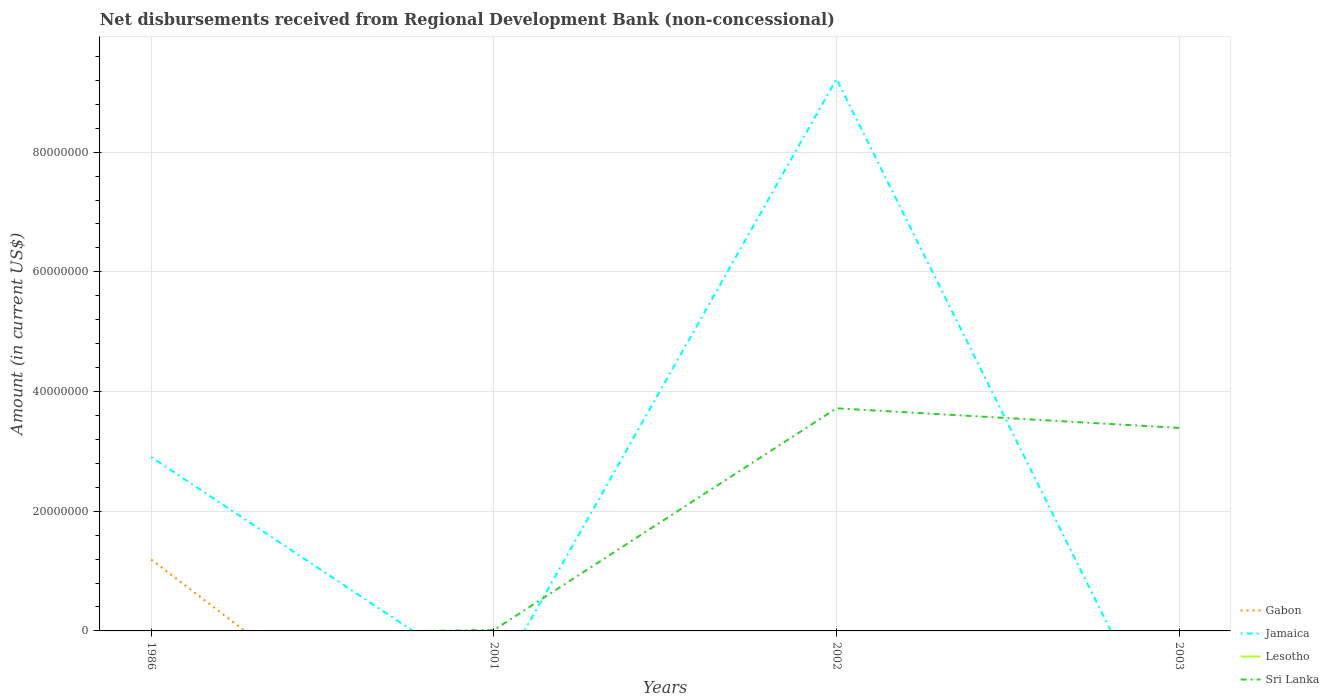Is the number of lines equal to the number of legend labels?
Offer a very short reply. No. Across all years, what is the maximum amount of disbursements received from Regional Development Bank in Jamaica?
Ensure brevity in your answer.  0. What is the total amount of disbursements received from Regional Development Bank in Sri Lanka in the graph?
Provide a short and direct response. 3.28e+06. What is the difference between the highest and the second highest amount of disbursements received from Regional Development Bank in Jamaica?
Give a very brief answer. 9.22e+07. What is the difference between the highest and the lowest amount of disbursements received from Regional Development Bank in Jamaica?
Offer a terse response. 1. How many years are there in the graph?
Your response must be concise. 4. What is the difference between two consecutive major ticks on the Y-axis?
Offer a very short reply. 2.00e+07. Are the values on the major ticks of Y-axis written in scientific E-notation?
Keep it short and to the point. No. Does the graph contain grids?
Offer a very short reply. Yes. How many legend labels are there?
Keep it short and to the point. 4. What is the title of the graph?
Your answer should be compact. Net disbursements received from Regional Development Bank (non-concessional). Does "Ireland" appear as one of the legend labels in the graph?
Offer a very short reply. No. What is the Amount (in current US$) in Gabon in 1986?
Keep it short and to the point. 1.19e+07. What is the Amount (in current US$) in Jamaica in 1986?
Your response must be concise. 2.91e+07. What is the Amount (in current US$) of Lesotho in 1986?
Give a very brief answer. 0. What is the Amount (in current US$) in Gabon in 2001?
Offer a very short reply. 0. What is the Amount (in current US$) of Jamaica in 2001?
Offer a terse response. 0. What is the Amount (in current US$) of Lesotho in 2001?
Your answer should be very brief. 0. What is the Amount (in current US$) of Sri Lanka in 2001?
Make the answer very short. 1.50e+05. What is the Amount (in current US$) in Jamaica in 2002?
Make the answer very short. 9.22e+07. What is the Amount (in current US$) of Sri Lanka in 2002?
Give a very brief answer. 3.72e+07. What is the Amount (in current US$) of Jamaica in 2003?
Your answer should be very brief. 0. What is the Amount (in current US$) in Sri Lanka in 2003?
Keep it short and to the point. 3.39e+07. Across all years, what is the maximum Amount (in current US$) of Gabon?
Offer a terse response. 1.19e+07. Across all years, what is the maximum Amount (in current US$) in Jamaica?
Offer a very short reply. 9.22e+07. Across all years, what is the maximum Amount (in current US$) in Sri Lanka?
Keep it short and to the point. 3.72e+07. Across all years, what is the minimum Amount (in current US$) of Gabon?
Give a very brief answer. 0. Across all years, what is the minimum Amount (in current US$) in Jamaica?
Offer a terse response. 0. Across all years, what is the minimum Amount (in current US$) in Sri Lanka?
Make the answer very short. 0. What is the total Amount (in current US$) in Gabon in the graph?
Provide a succinct answer. 1.19e+07. What is the total Amount (in current US$) in Jamaica in the graph?
Your answer should be very brief. 1.21e+08. What is the total Amount (in current US$) in Lesotho in the graph?
Keep it short and to the point. 0. What is the total Amount (in current US$) of Sri Lanka in the graph?
Your answer should be compact. 7.13e+07. What is the difference between the Amount (in current US$) of Jamaica in 1986 and that in 2002?
Your answer should be very brief. -6.32e+07. What is the difference between the Amount (in current US$) of Sri Lanka in 2001 and that in 2002?
Your answer should be compact. -3.70e+07. What is the difference between the Amount (in current US$) of Sri Lanka in 2001 and that in 2003?
Provide a succinct answer. -3.38e+07. What is the difference between the Amount (in current US$) of Sri Lanka in 2002 and that in 2003?
Keep it short and to the point. 3.28e+06. What is the difference between the Amount (in current US$) of Gabon in 1986 and the Amount (in current US$) of Sri Lanka in 2001?
Ensure brevity in your answer.  1.18e+07. What is the difference between the Amount (in current US$) of Jamaica in 1986 and the Amount (in current US$) of Sri Lanka in 2001?
Keep it short and to the point. 2.89e+07. What is the difference between the Amount (in current US$) in Gabon in 1986 and the Amount (in current US$) in Jamaica in 2002?
Offer a very short reply. -8.03e+07. What is the difference between the Amount (in current US$) of Gabon in 1986 and the Amount (in current US$) of Sri Lanka in 2002?
Give a very brief answer. -2.53e+07. What is the difference between the Amount (in current US$) of Jamaica in 1986 and the Amount (in current US$) of Sri Lanka in 2002?
Your response must be concise. -8.15e+06. What is the difference between the Amount (in current US$) in Gabon in 1986 and the Amount (in current US$) in Sri Lanka in 2003?
Offer a very short reply. -2.20e+07. What is the difference between the Amount (in current US$) in Jamaica in 1986 and the Amount (in current US$) in Sri Lanka in 2003?
Your answer should be very brief. -4.87e+06. What is the difference between the Amount (in current US$) in Jamaica in 2002 and the Amount (in current US$) in Sri Lanka in 2003?
Make the answer very short. 5.83e+07. What is the average Amount (in current US$) of Gabon per year?
Give a very brief answer. 2.98e+06. What is the average Amount (in current US$) of Jamaica per year?
Provide a short and direct response. 3.03e+07. What is the average Amount (in current US$) of Lesotho per year?
Offer a terse response. 0. What is the average Amount (in current US$) in Sri Lanka per year?
Your response must be concise. 1.78e+07. In the year 1986, what is the difference between the Amount (in current US$) in Gabon and Amount (in current US$) in Jamaica?
Make the answer very short. -1.71e+07. In the year 2002, what is the difference between the Amount (in current US$) of Jamaica and Amount (in current US$) of Sri Lanka?
Give a very brief answer. 5.50e+07. What is the ratio of the Amount (in current US$) in Jamaica in 1986 to that in 2002?
Your answer should be very brief. 0.32. What is the ratio of the Amount (in current US$) in Sri Lanka in 2001 to that in 2002?
Ensure brevity in your answer.  0. What is the ratio of the Amount (in current US$) of Sri Lanka in 2001 to that in 2003?
Offer a very short reply. 0. What is the ratio of the Amount (in current US$) of Sri Lanka in 2002 to that in 2003?
Ensure brevity in your answer.  1.1. What is the difference between the highest and the second highest Amount (in current US$) of Sri Lanka?
Provide a short and direct response. 3.28e+06. What is the difference between the highest and the lowest Amount (in current US$) in Gabon?
Ensure brevity in your answer.  1.19e+07. What is the difference between the highest and the lowest Amount (in current US$) of Jamaica?
Make the answer very short. 9.22e+07. What is the difference between the highest and the lowest Amount (in current US$) in Sri Lanka?
Make the answer very short. 3.72e+07. 